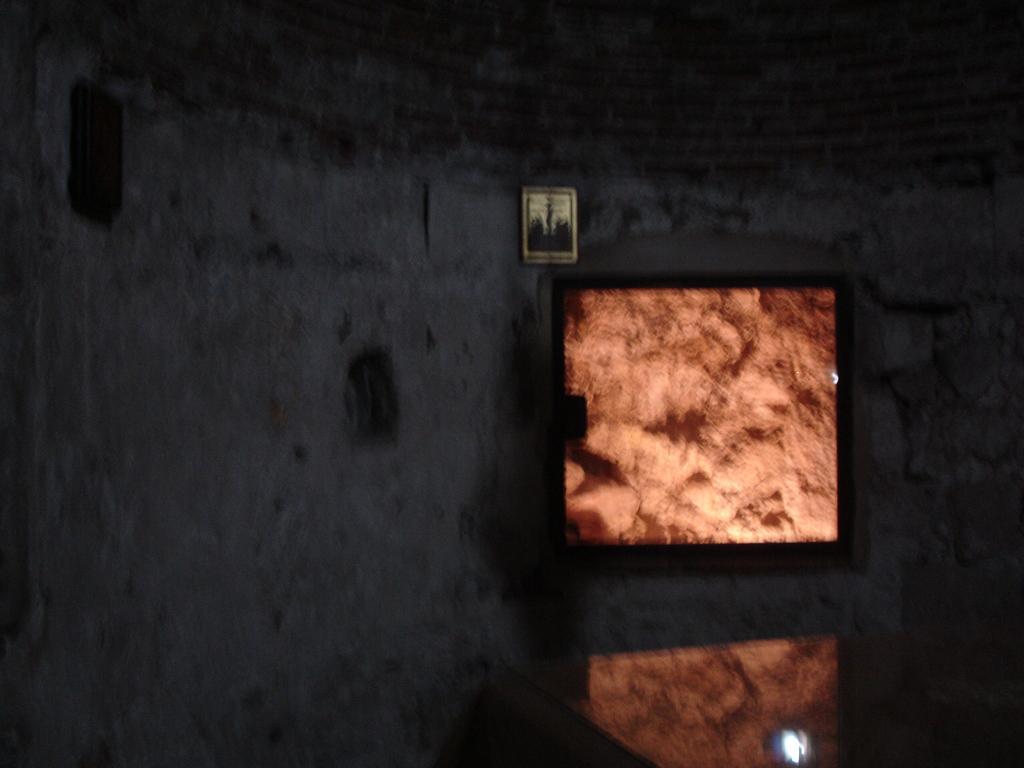Can you describe this image briefly? This picture is blur, in this picture we can see frame on the wall and objects. 